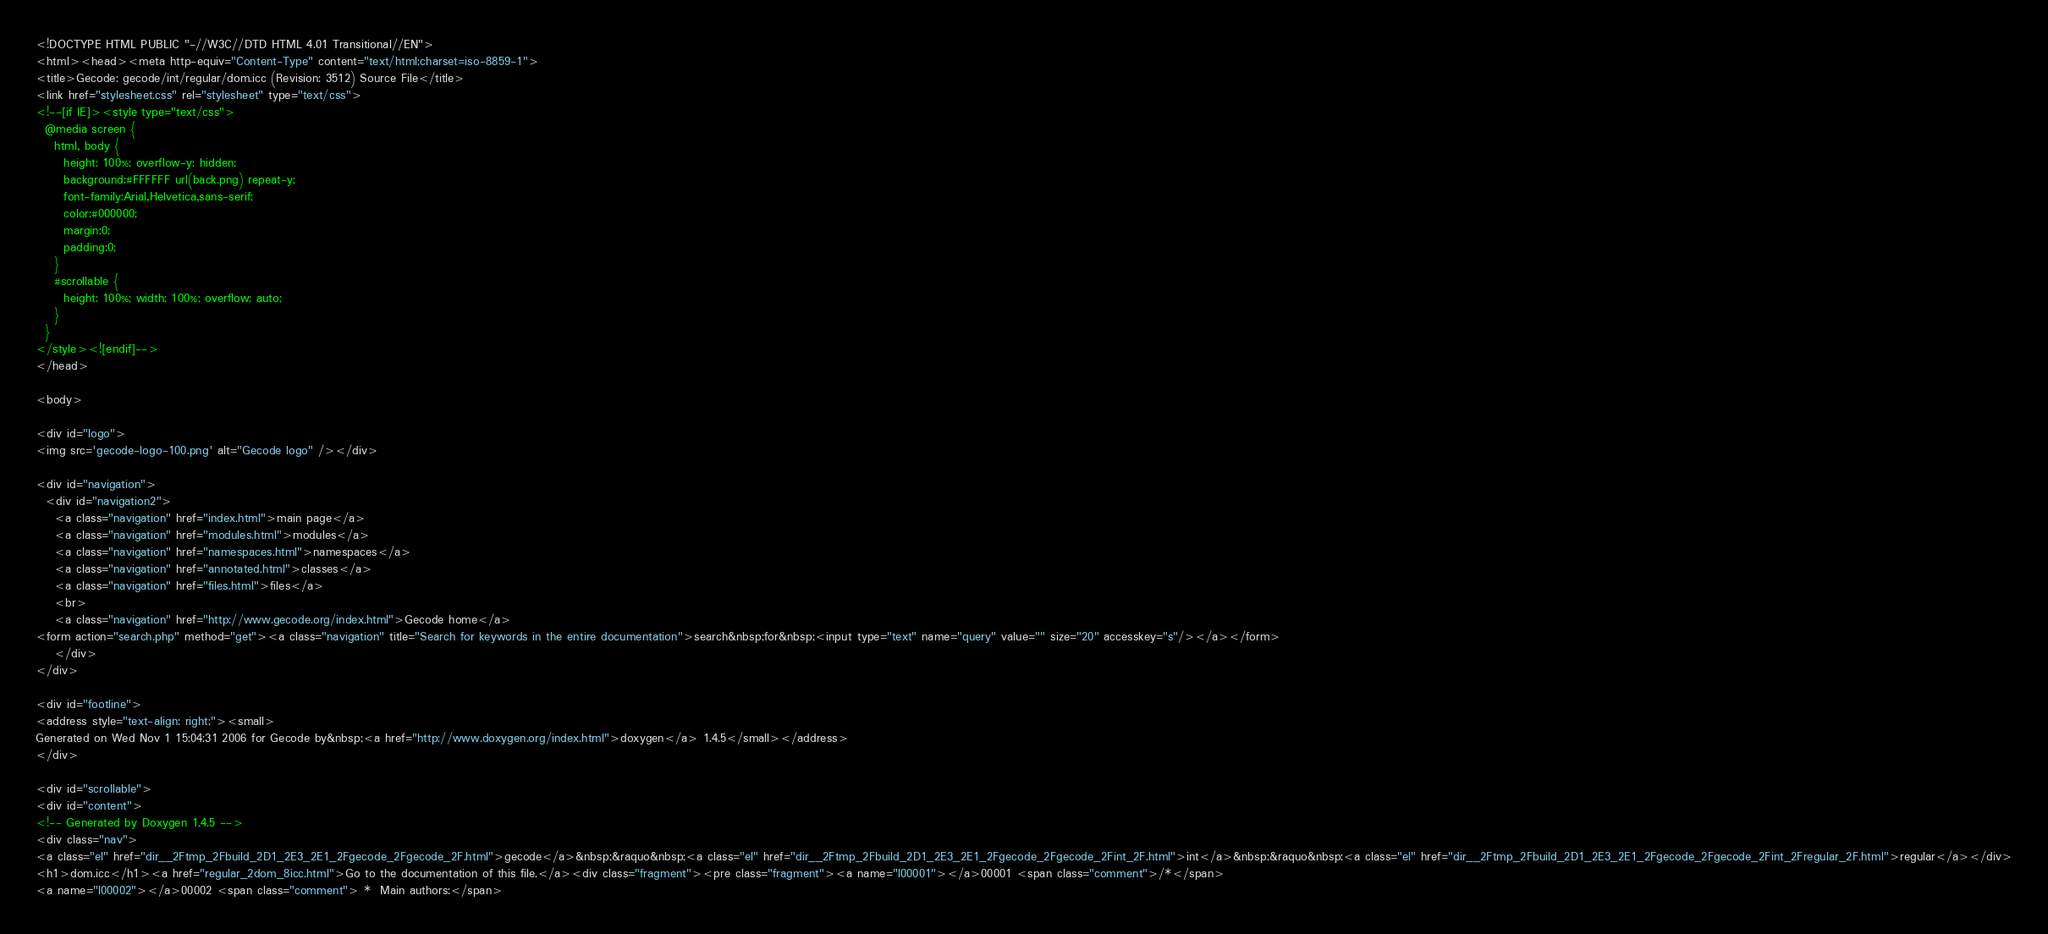<code> <loc_0><loc_0><loc_500><loc_500><_HTML_><!DOCTYPE HTML PUBLIC "-//W3C//DTD HTML 4.01 Transitional//EN">
<html><head><meta http-equiv="Content-Type" content="text/html;charset=iso-8859-1">
<title>Gecode: gecode/int/regular/dom.icc (Revision: 3512) Source File</title>
<link href="stylesheet.css" rel="stylesheet" type="text/css">
<!--[if IE]><style type="text/css">
  @media screen {
    html, body {
      height: 100%; overflow-y: hidden;
      background:#FFFFFF url(back.png) repeat-y;
      font-family:Arial,Helvetica,sans-serif;
      color:#000000;
      margin:0;
      padding:0;
    }
    #scrollable {
      height: 100%; width: 100%; overflow: auto;
    }
  }
</style><![endif]-->
</head>

<body>

<div id="logo">
<img src='gecode-logo-100.png' alt="Gecode logo" /></div>

<div id="navigation">
  <div id="navigation2">
    <a class="navigation" href="index.html">main page</a>
    <a class="navigation" href="modules.html">modules</a>
    <a class="navigation" href="namespaces.html">namespaces</a>
    <a class="navigation" href="annotated.html">classes</a>
    <a class="navigation" href="files.html">files</a>
    <br>
    <a class="navigation" href="http://www.gecode.org/index.html">Gecode home</a>
<form action="search.php" method="get"><a class="navigation" title="Search for keywords in the entire documentation">search&nbsp;for&nbsp;<input type="text" name="query" value="" size="20" accesskey="s"/></a></form>
    </div>
</div>

<div id="footline">
<address style="text-align: right;"><small>
Generated on Wed Nov 1 15:04:31 2006 for Gecode by&nbsp;<a href="http://www.doxygen.org/index.html">doxygen</a> 1.4.5</small></address>
</div>

<div id="scrollable">
<div id="content">
<!-- Generated by Doxygen 1.4.5 -->
<div class="nav">
<a class="el" href="dir__2Ftmp_2Fbuild_2D1_2E3_2E1_2Fgecode_2Fgecode_2F.html">gecode</a>&nbsp;&raquo&nbsp;<a class="el" href="dir__2Ftmp_2Fbuild_2D1_2E3_2E1_2Fgecode_2Fgecode_2Fint_2F.html">int</a>&nbsp;&raquo&nbsp;<a class="el" href="dir__2Ftmp_2Fbuild_2D1_2E3_2E1_2Fgecode_2Fgecode_2Fint_2Fregular_2F.html">regular</a></div>
<h1>dom.icc</h1><a href="regular_2dom_8icc.html">Go to the documentation of this file.</a><div class="fragment"><pre class="fragment"><a name="l00001"></a>00001 <span class="comment">/*</span>
<a name="l00002"></a>00002 <span class="comment"> *  Main authors:</span></code> 